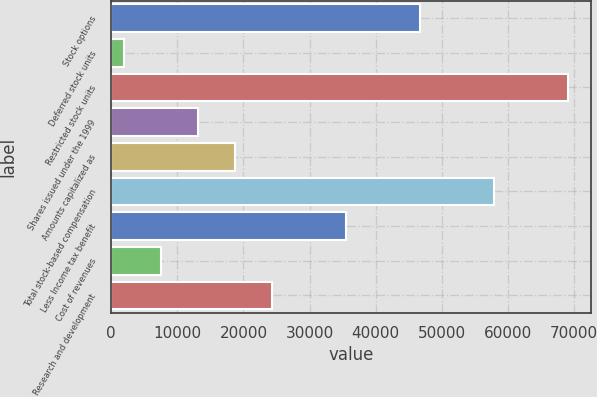Convert chart to OTSL. <chart><loc_0><loc_0><loc_500><loc_500><bar_chart><fcel>Stock options<fcel>Deferred stock units<fcel>Restricted stock units<fcel>Shares issued under the 1999<fcel>Amounts capitalized as<fcel>Total stock-based compensation<fcel>Less Income tax benefit<fcel>Cost of revenues<fcel>Research and development<nl><fcel>46696.2<fcel>1885<fcel>69101.8<fcel>13087.8<fcel>18689.2<fcel>57899<fcel>35493.4<fcel>7486.4<fcel>24290.6<nl></chart> 